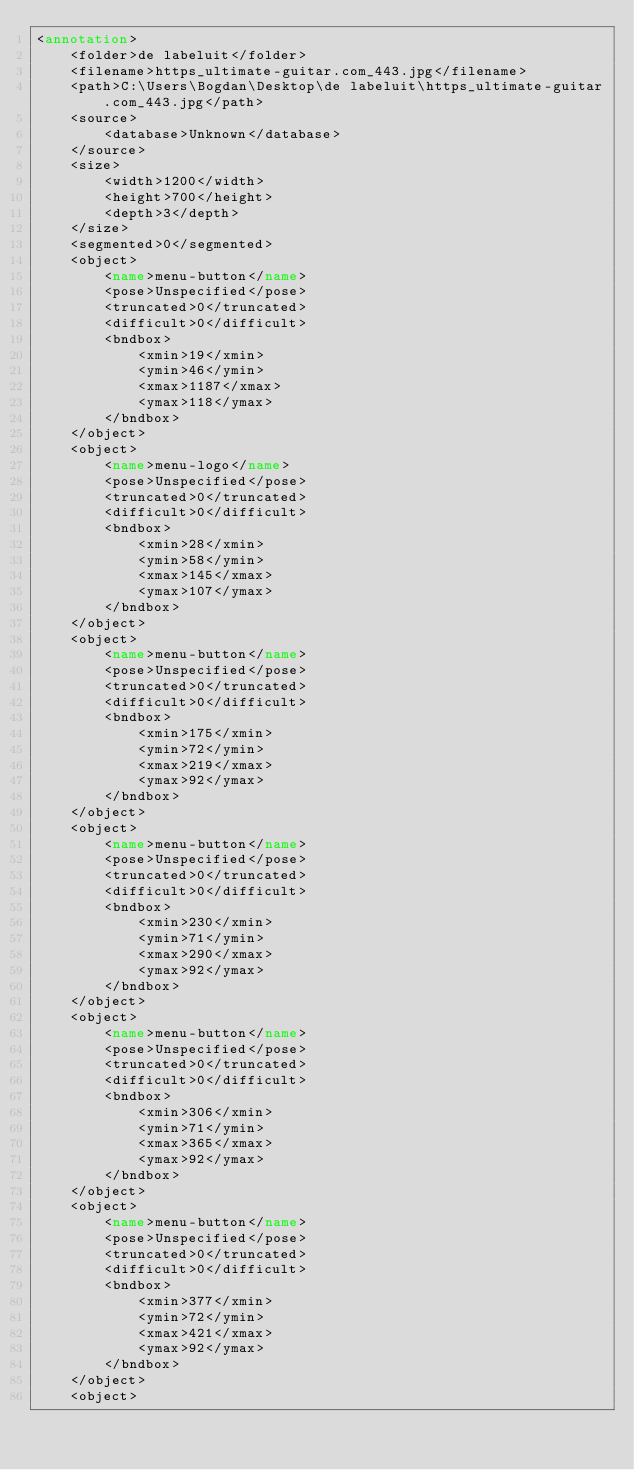Convert code to text. <code><loc_0><loc_0><loc_500><loc_500><_XML_><annotation>
	<folder>de labeluit</folder>
	<filename>https_ultimate-guitar.com_443.jpg</filename>
	<path>C:\Users\Bogdan\Desktop\de labeluit\https_ultimate-guitar.com_443.jpg</path>
	<source>
		<database>Unknown</database>
	</source>
	<size>
		<width>1200</width>
		<height>700</height>
		<depth>3</depth>
	</size>
	<segmented>0</segmented>
	<object>
		<name>menu-button</name>
		<pose>Unspecified</pose>
		<truncated>0</truncated>
		<difficult>0</difficult>
		<bndbox>
			<xmin>19</xmin>
			<ymin>46</ymin>
			<xmax>1187</xmax>
			<ymax>118</ymax>
		</bndbox>
	</object>
	<object>
		<name>menu-logo</name>
		<pose>Unspecified</pose>
		<truncated>0</truncated>
		<difficult>0</difficult>
		<bndbox>
			<xmin>28</xmin>
			<ymin>58</ymin>
			<xmax>145</xmax>
			<ymax>107</ymax>
		</bndbox>
	</object>
	<object>
		<name>menu-button</name>
		<pose>Unspecified</pose>
		<truncated>0</truncated>
		<difficult>0</difficult>
		<bndbox>
			<xmin>175</xmin>
			<ymin>72</ymin>
			<xmax>219</xmax>
			<ymax>92</ymax>
		</bndbox>
	</object>
	<object>
		<name>menu-button</name>
		<pose>Unspecified</pose>
		<truncated>0</truncated>
		<difficult>0</difficult>
		<bndbox>
			<xmin>230</xmin>
			<ymin>71</ymin>
			<xmax>290</xmax>
			<ymax>92</ymax>
		</bndbox>
	</object>
	<object>
		<name>menu-button</name>
		<pose>Unspecified</pose>
		<truncated>0</truncated>
		<difficult>0</difficult>
		<bndbox>
			<xmin>306</xmin>
			<ymin>71</ymin>
			<xmax>365</xmax>
			<ymax>92</ymax>
		</bndbox>
	</object>
	<object>
		<name>menu-button</name>
		<pose>Unspecified</pose>
		<truncated>0</truncated>
		<difficult>0</difficult>
		<bndbox>
			<xmin>377</xmin>
			<ymin>72</ymin>
			<xmax>421</xmax>
			<ymax>92</ymax>
		</bndbox>
	</object>
	<object></code> 